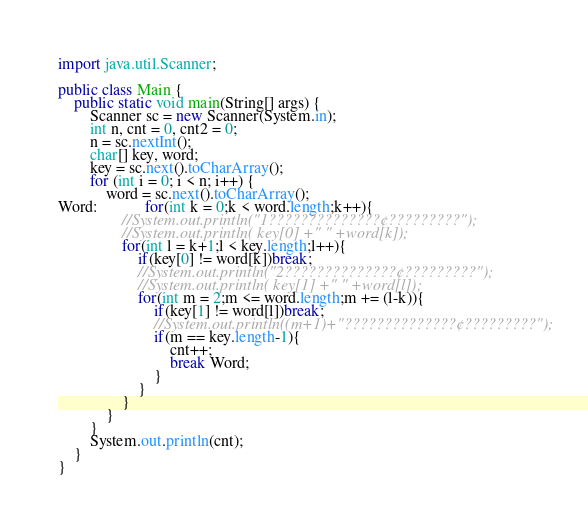<code> <loc_0><loc_0><loc_500><loc_500><_Java_>import java.util.Scanner;

public class Main {
	public static void main(String[] args) {
		Scanner sc = new Scanner(System.in);
		int n, cnt = 0, cnt2 = 0;
		n = sc.nextInt();
		char[] key, word;
		key = sc.next().toCharArray();
		for (int i = 0; i < n; i++) {
			word = sc.next().toCharArray();
Word:			for(int k = 0;k < word.length;k++){
				//System.out.println("1??????????????¢?????????");
				//System.out.println( key[0] +" " +word[k]);
				for(int l = k+1;l < key.length;l++){
					if(key[0] != word[k])break;
					//System.out.println("2??????????????¢?????????");
					//System.out.println( key[1] +" " +word[l]);
					for(int m = 2;m <= word.length;m += (l-k)){
						if(key[1] != word[l])break;
						//System.out.println((m+1)+"??????????????¢?????????");
						if(m == key.length-1){
							cnt++;
							break Word;
						}
					}
				}
			}
		}
		System.out.println(cnt);
	}
}</code> 